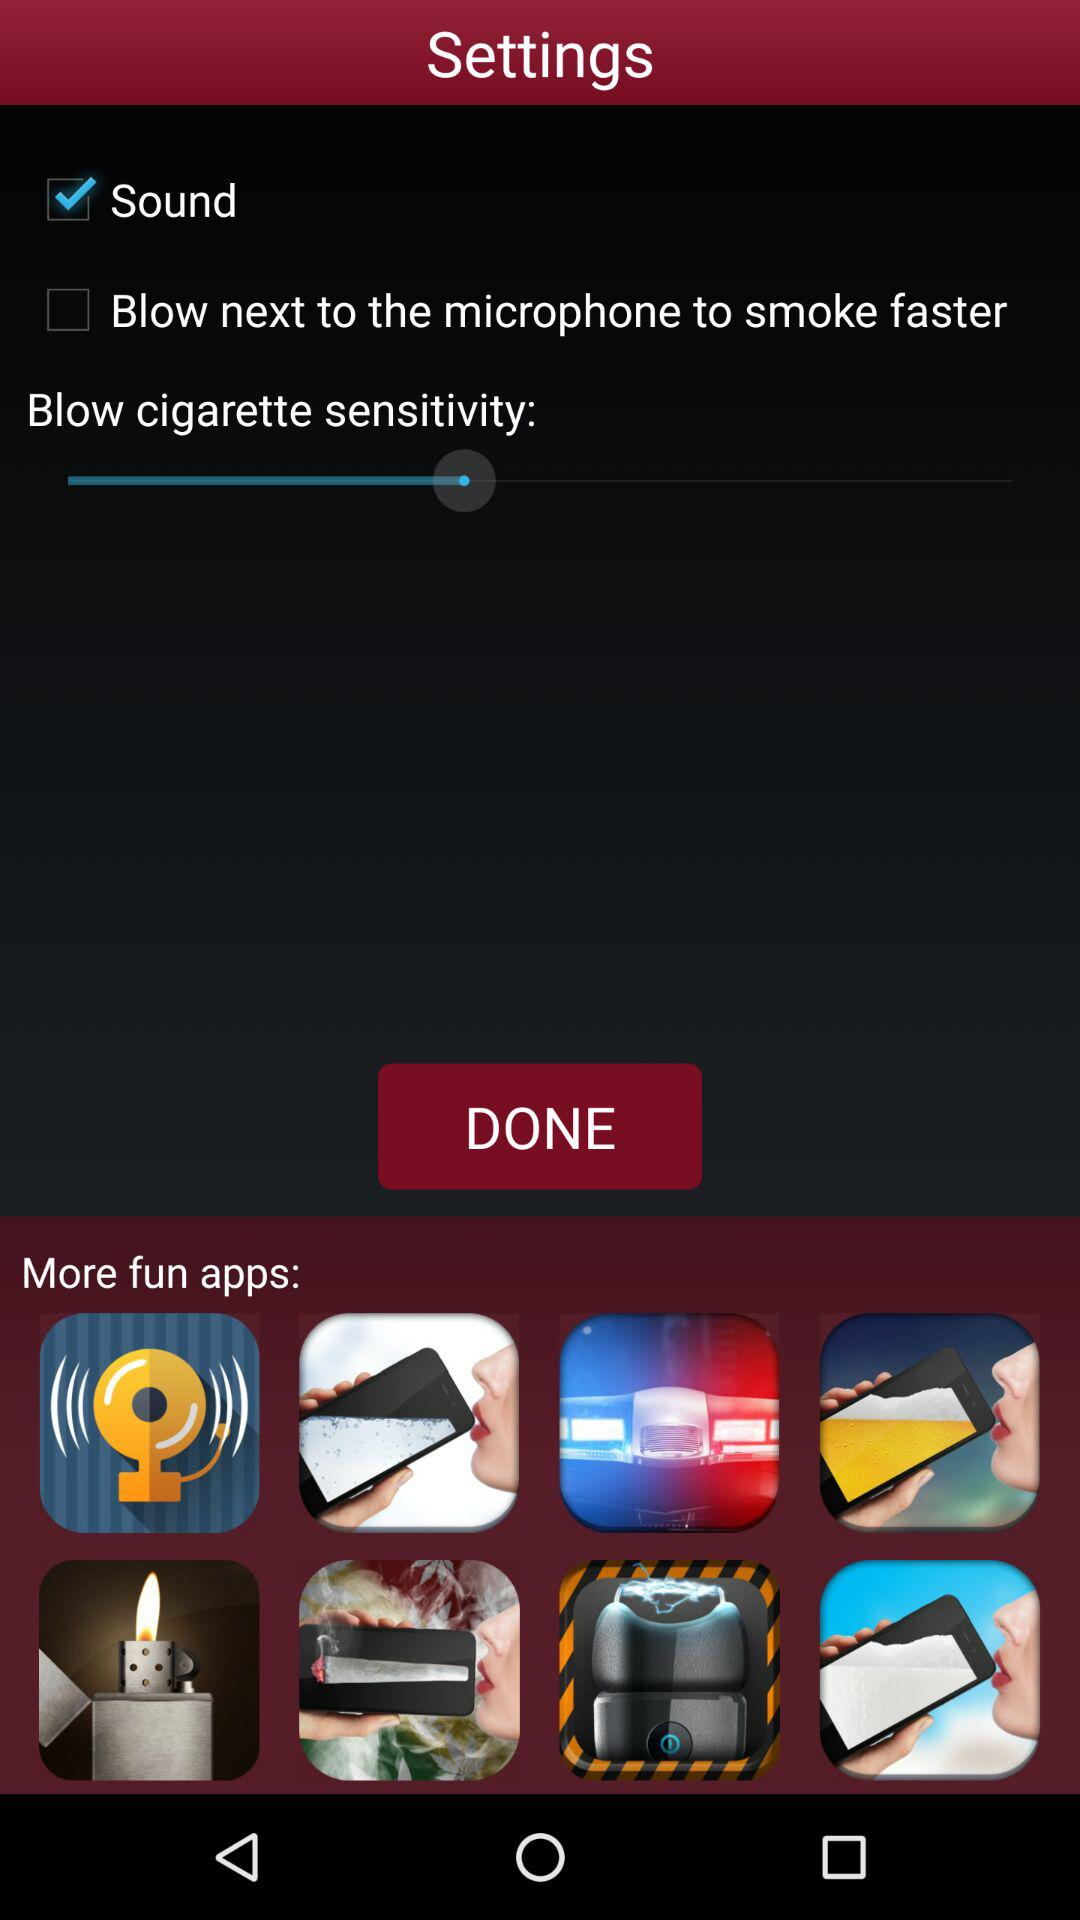Which settings are checked? The checked setting is "Sound". 